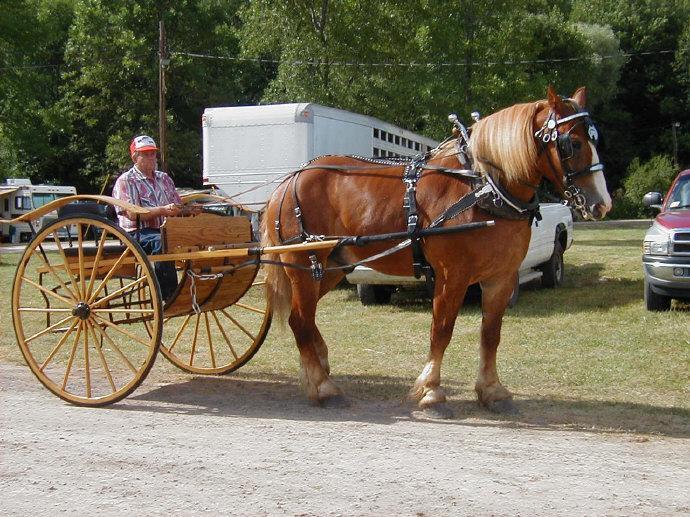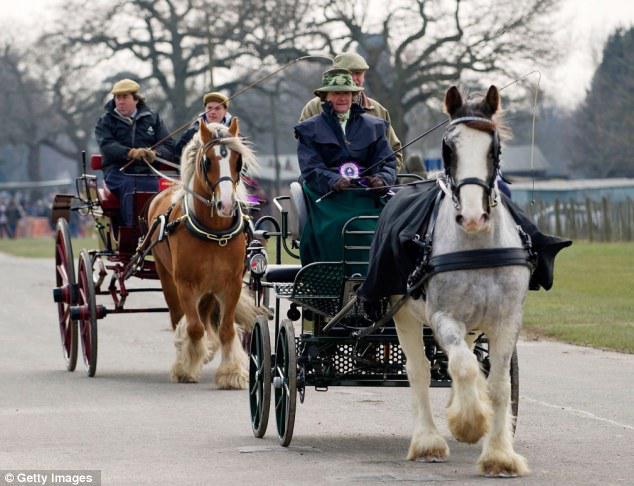The first image is the image on the left, the second image is the image on the right. For the images shown, is this caption "In one of the images the wagon is being pulled by two horses." true? Answer yes or no. No. 